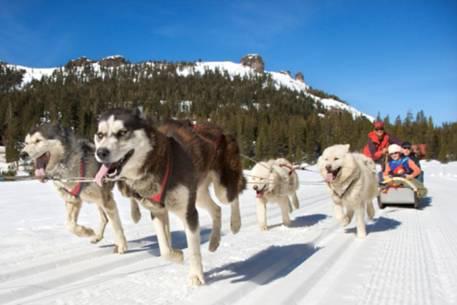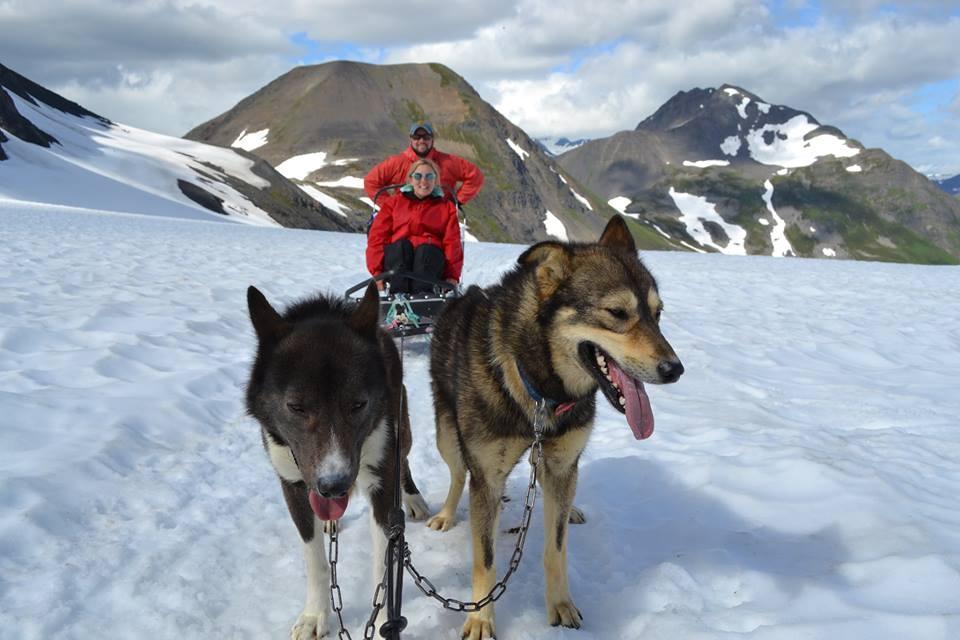The first image is the image on the left, the second image is the image on the right. For the images shown, is this caption "There are at least three humans in the right image." true? Answer yes or no. No. The first image is the image on the left, the second image is the image on the right. Analyze the images presented: Is the assertion "An image shows a team of sled dogs wearing matching booties." valid? Answer yes or no. No. 